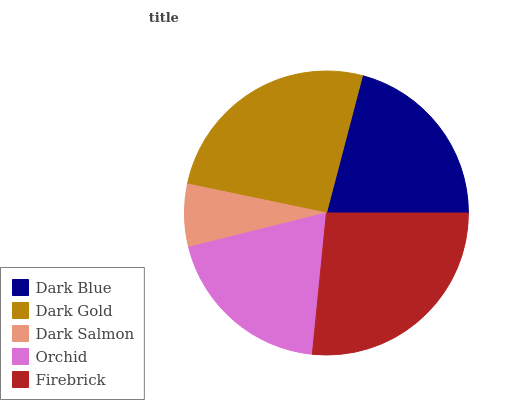Is Dark Salmon the minimum?
Answer yes or no. Yes. Is Firebrick the maximum?
Answer yes or no. Yes. Is Dark Gold the minimum?
Answer yes or no. No. Is Dark Gold the maximum?
Answer yes or no. No. Is Dark Gold greater than Dark Blue?
Answer yes or no. Yes. Is Dark Blue less than Dark Gold?
Answer yes or no. Yes. Is Dark Blue greater than Dark Gold?
Answer yes or no. No. Is Dark Gold less than Dark Blue?
Answer yes or no. No. Is Dark Blue the high median?
Answer yes or no. Yes. Is Dark Blue the low median?
Answer yes or no. Yes. Is Orchid the high median?
Answer yes or no. No. Is Firebrick the low median?
Answer yes or no. No. 